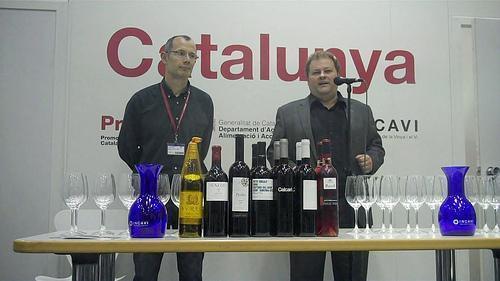How many people are in this picture?
Give a very brief answer. 2. 